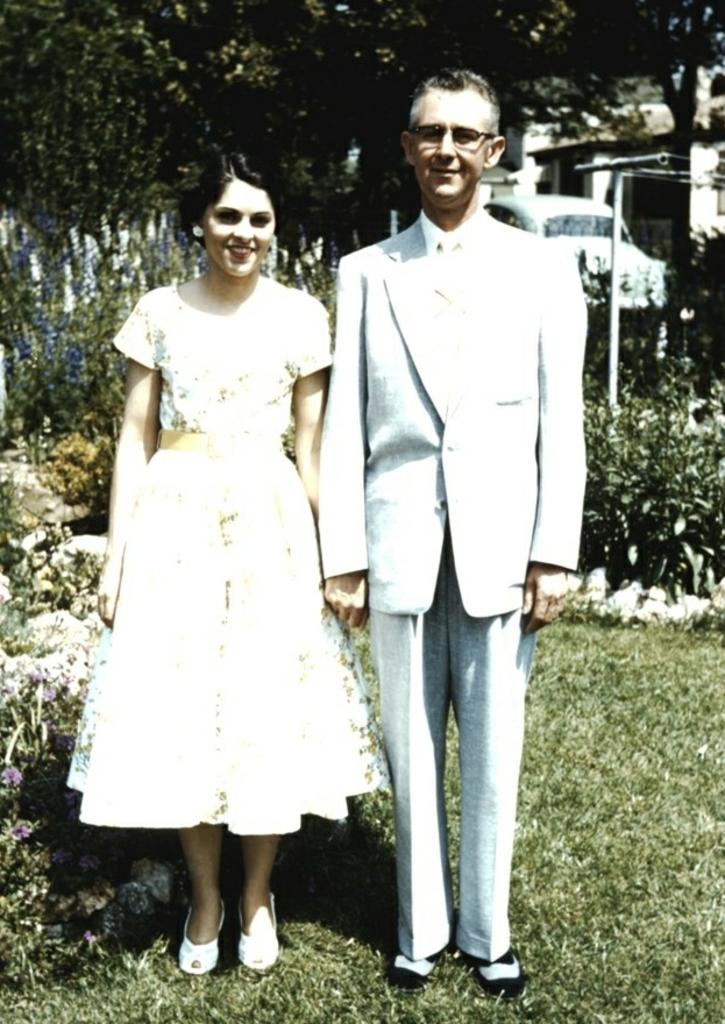How many people are present in the image? There are two people, a man and a woman, present in the image. What is the ground surface like in the image? Grass is visible in the image. What type of vegetation can be seen with flowers in the image? There are plants with flowers in the image. What type of structure is visible in the image? There is a building in the image. What is the man and woman standing near in the image? There is a pole with wires and a car in the image. What other natural elements can be seen in the image? There are trees in the image. What type of scientific experiment is being conducted by the man and woman in the image? There is no indication of a scientific experiment being conducted in the image. Can you tell me how many turkeys are visible in the image? There are no turkeys present in the image. 